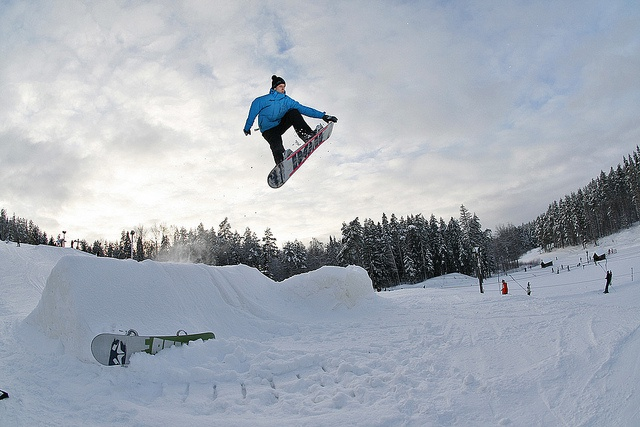Describe the objects in this image and their specific colors. I can see people in darkgray, black, blue, and navy tones, snowboard in darkgray, gray, and black tones, snowboard in darkgray, gray, and black tones, people in darkgray, black, purple, navy, and violet tones, and people in darkgray, maroon, black, and gray tones in this image. 